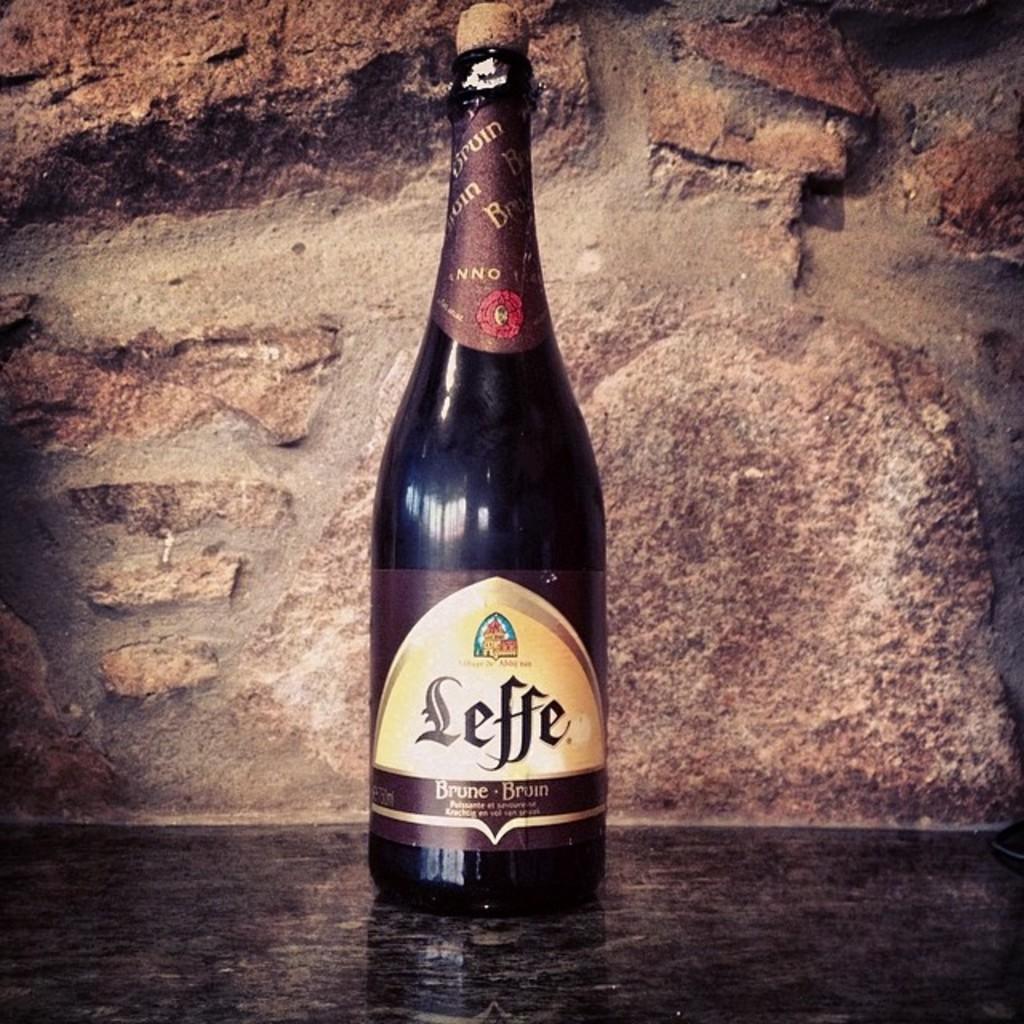What does it say underneath the brand name of this wine?
Keep it short and to the point. Brune bruin. 